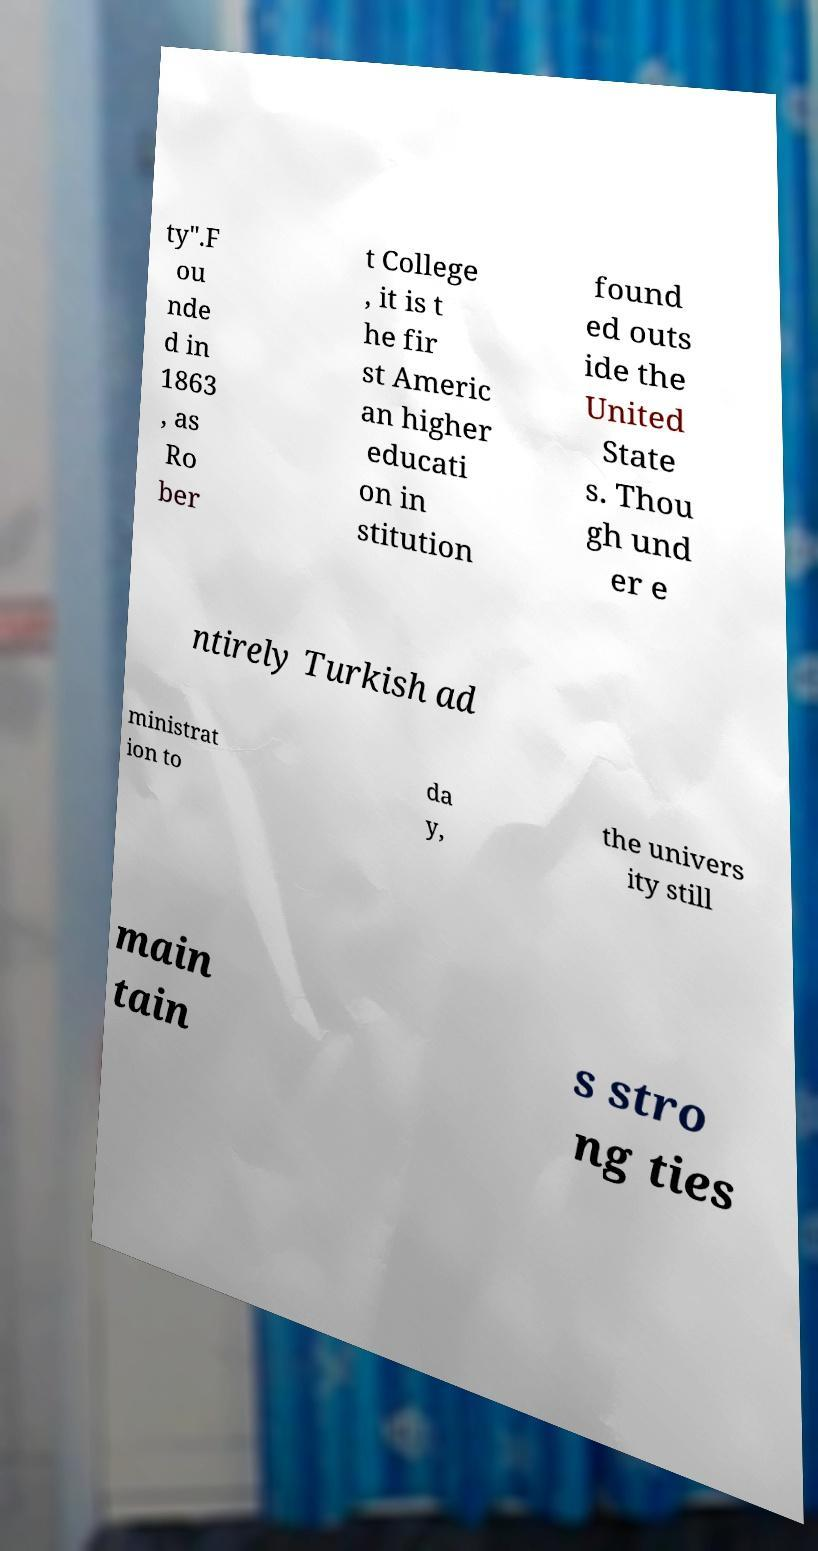What messages or text are displayed in this image? I need them in a readable, typed format. ty".F ou nde d in 1863 , as Ro ber t College , it is t he fir st Americ an higher educati on in stitution found ed outs ide the United State s. Thou gh und er e ntirely Turkish ad ministrat ion to da y, the univers ity still main tain s stro ng ties 